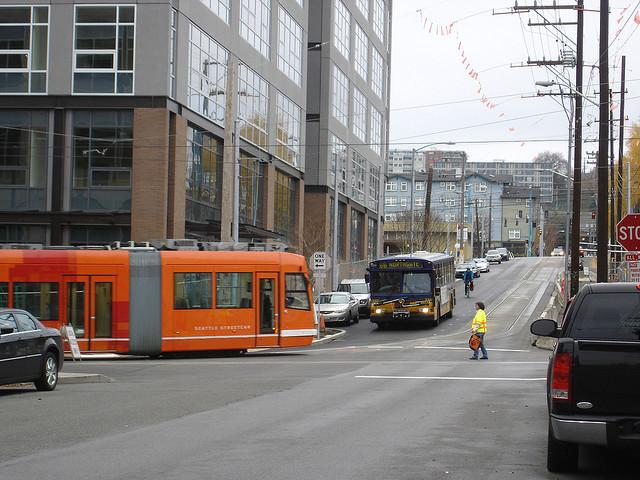What is the reason for the woman in yellow standing in the street here? directing traffic 